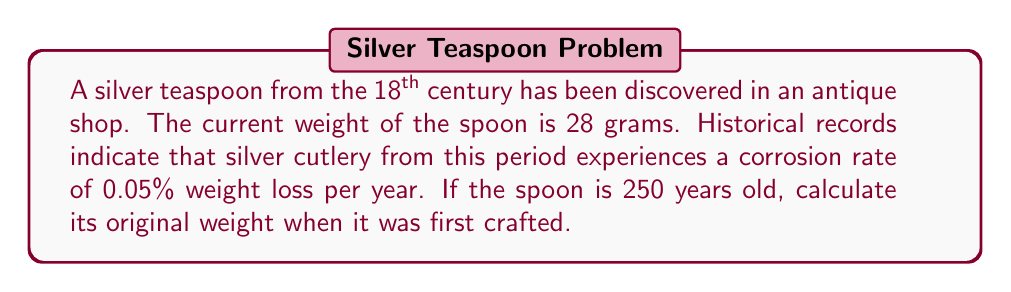Can you answer this question? To solve this inverse problem, we need to work backwards from the current weight to determine the original weight. Let's approach this step-by-step:

1) Let $w_0$ be the original weight and $w_f$ be the final (current) weight.

2) The corrosion rate is 0.05% per year, which means the spoon retains 99.95% of its weight each year.

3) Over 250 years, the weight retention factor is:
   $$(0.9995)^{250}$$

4) We can express this relationship as:
   $$w_f = w_0 \cdot (0.9995)^{250}$$

5) We know $w_f = 28$ grams, so we can write:
   $$28 = w_0 \cdot (0.9995)^{250}$$

6) Solving for $w_0$:
   $$w_0 = \frac{28}{(0.9995)^{250}}$$

7) Calculate $(0.9995)^{250}$ using a calculator:
   $$(0.9995)^{250} \approx 0.8825$$

8) Now we can find $w_0$:
   $$w_0 = \frac{28}{0.8825} \approx 31.73 \text{ grams}$$

Therefore, the original weight of the silver teaspoon was approximately 31.73 grams.
Answer: 31.73 grams 